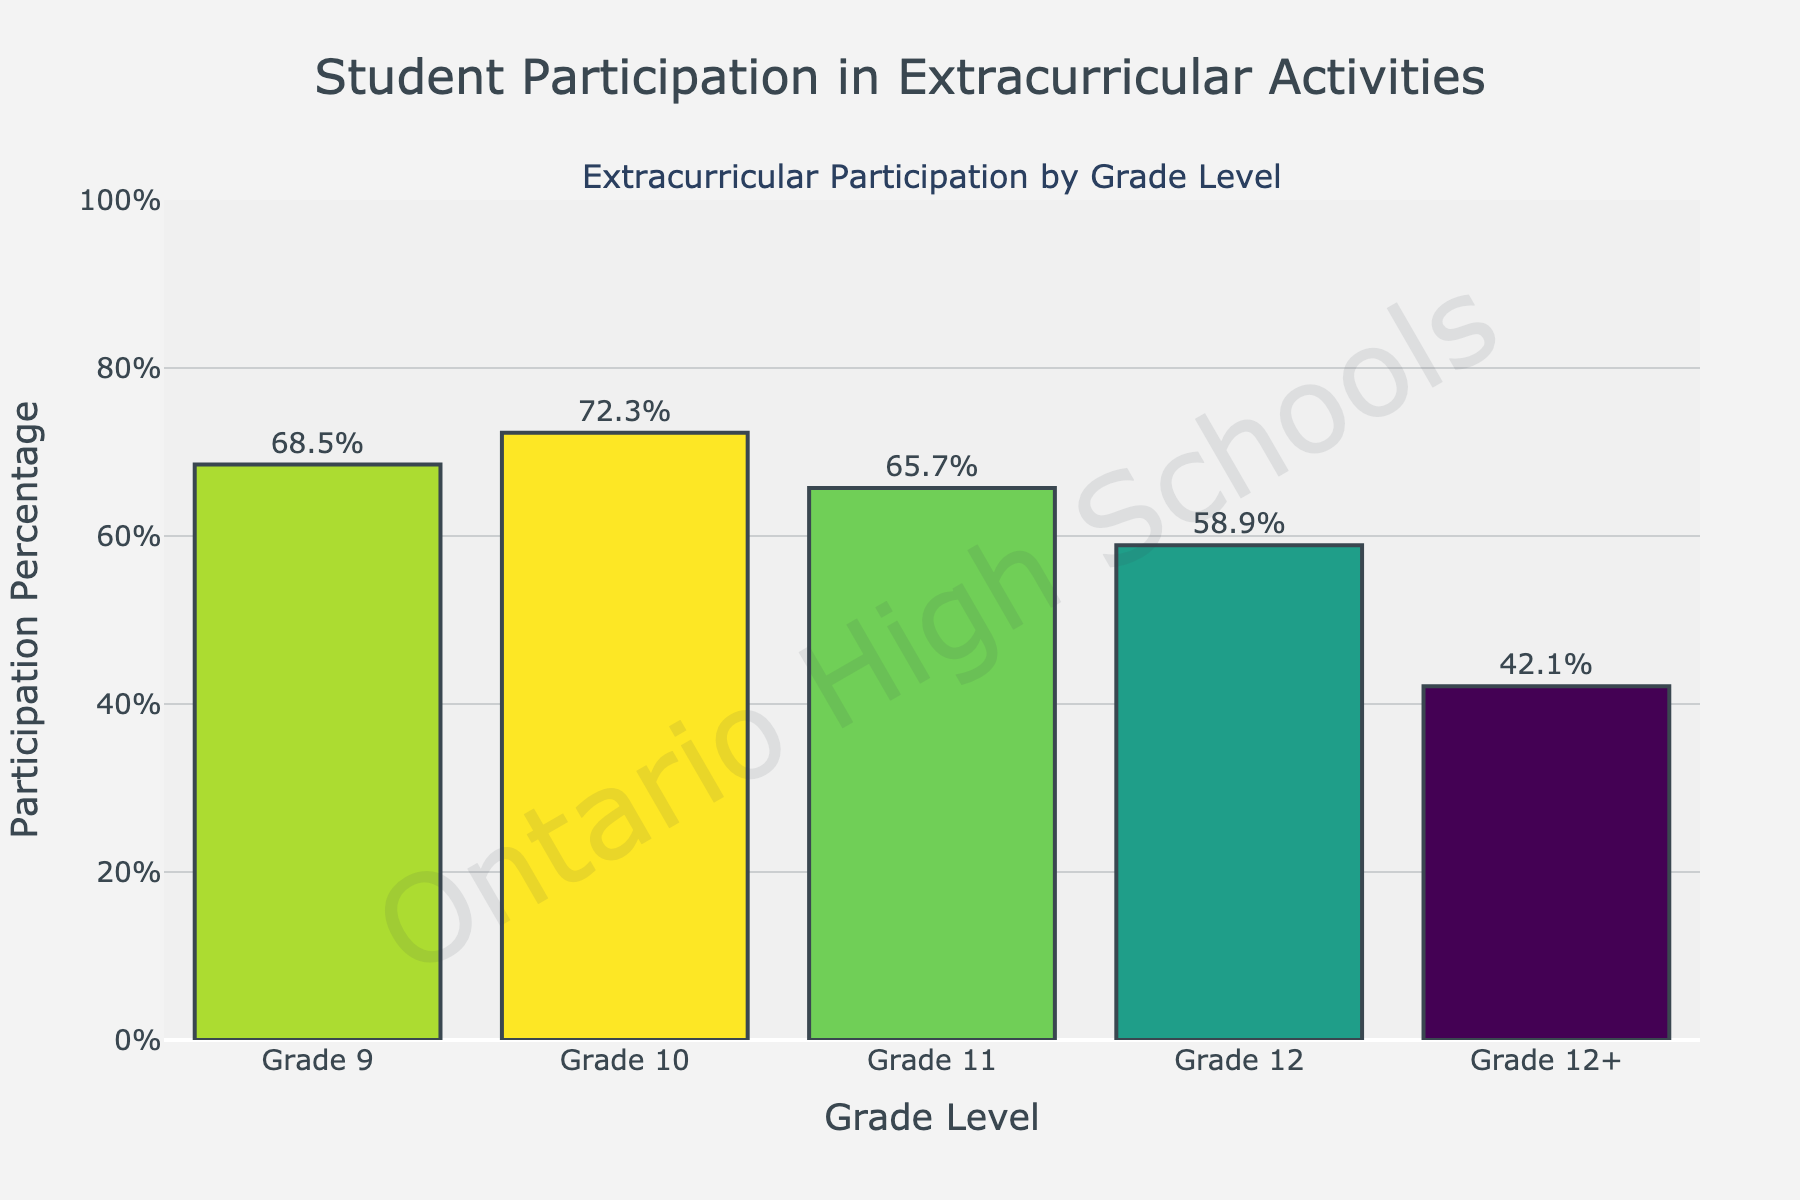What grade has the highest percentage of participation in extracurricular activities? The grade with the highest bar represents the highest percentage of participation. Grade 10 has the highest bar.
Answer: Grade 10 What is the difference in participation percentage between Grade 9 and Grade 12? Subtract the percentage of Grade 12 (58.9%) from Grade 9 (68.5%). The calculation is 68.5% - 58.9% = 9.6%.
Answer: 9.6% What is the average participation percentage for Grades 9 through 12? Add the percentages for Grades 9, 10, 11, and 12, then divide by the number of grades. The calculation is (68.5% + 72.3% + 65.7% + 58.9%) / 4 = 66.35%.
Answer: 66.35% Which grade has the lowest participation in extracurricular activities? The grade with the shortest bar represents the lowest participation. Grade 12+ has the shortest bar.
Answer: Grade 12+ How much lower is the participation percentage for Grade 12+ compared to Grade 11? Subtract the percentage of Grade 12+ (42.1%) from Grade 11 (65.7%). The calculation is 65.7% - 42.1% = 23.6%.
Answer: 23.6% Is the participation percentage in extracurricular activities generally decreasing or increasing as students progress in grades? By examining the pattern of the bar heights, the percentages generally decrease from Grade 9 to Grade 12+.
Answer: Decreasing What is the combined participation percentage for Grades 11 and 12? Add the percentages for Grades 11 and 12. The calculation is 65.7% + 58.9% = 124.6%.
Answer: 124.6% How much higher is the participation percentage of Grade 9 compared to Grade 12+? Subtract the percentage of Grade 12+ (42.1%) from Grade 9 (68.5%). The calculation is 68.5% - 42.1% = 26.4%.
Answer: 26.4% Between which two consecutive grades is the largest drop in participation percentage? Calculate the drop between each consecutive grade and find the largest. Grade 11 to Grade 12 drops by 65.7% - 58.9% = 6.8%; Grade 10 to Grade 11 drops by 72.3% - 65.7% = 6.6%; Grade 9 to Grade 10 increases. Grade 12 to Grade 12+ drops by 58.9% - 42.1% = 16.8%. The largest drop is between Grades 12 and 12+.
Answer: Grade 12 to Grade 12+ Which grade has a participation percentage closest to the overall average from Grades 9 to 12+? First find the overall average: (68.5% + 72.3% + 65.7% + 58.9% + 42.1%) / 5 = 61.5%. The closest percentages are 58.9% (Grade 12) and 65.7% (Grade 11). Grade 11 is closer.
Answer: Grade 11 